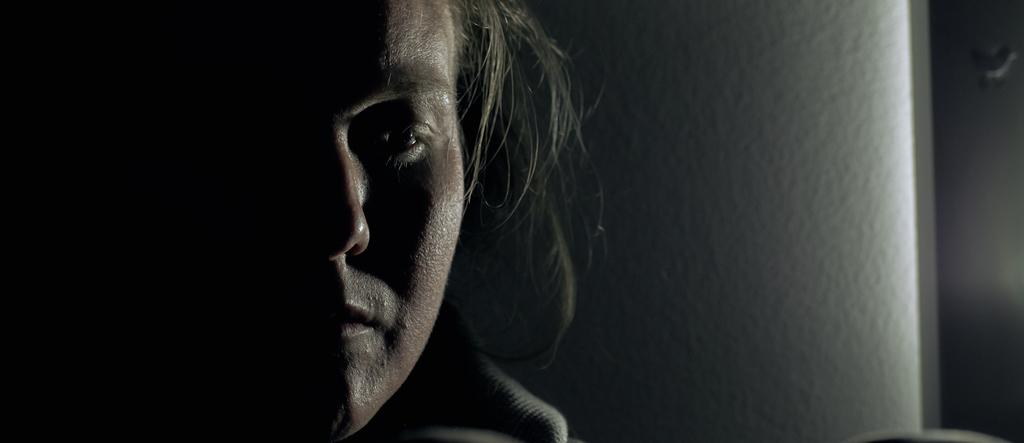What is the overall lighting condition in the image? The image is dark. What can be seen on the person's face in the image? There is a person's face visible in the image. What is located behind the person in the image? There is a wall in the background of the image. What type of flower is growing on the person's face in the image? There is no flower growing on the person's face in the image. 